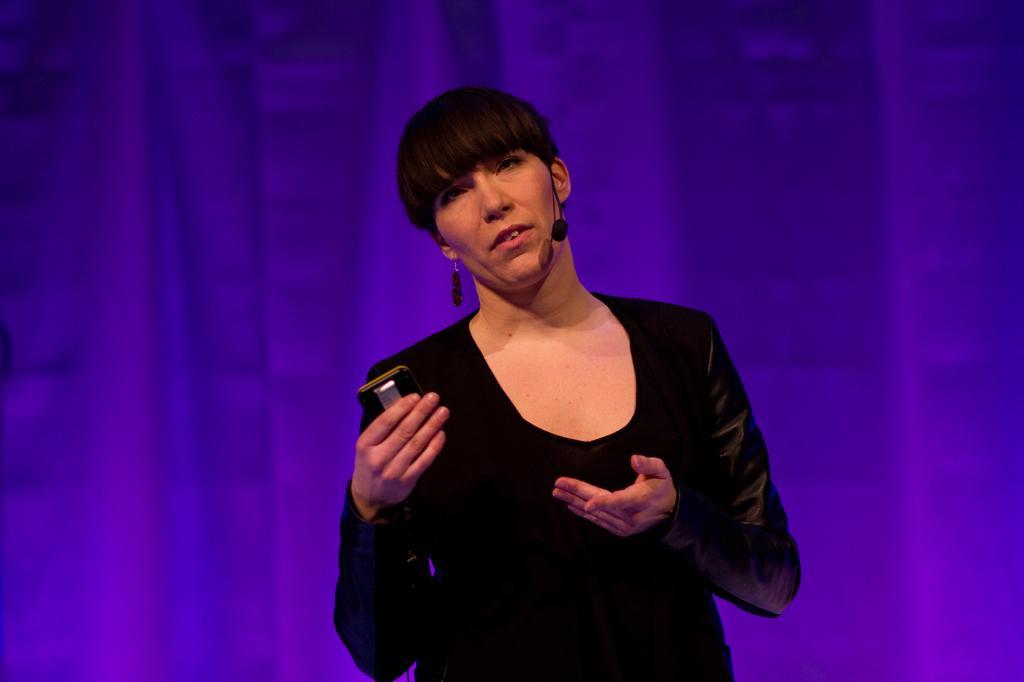How would you summarize this image in a sentence or two? In this picture I can see a woman standing in front and I see that she is wearing black color dress and holding a thing and I can see a mic near to her mouth and I can see the purple color background. 